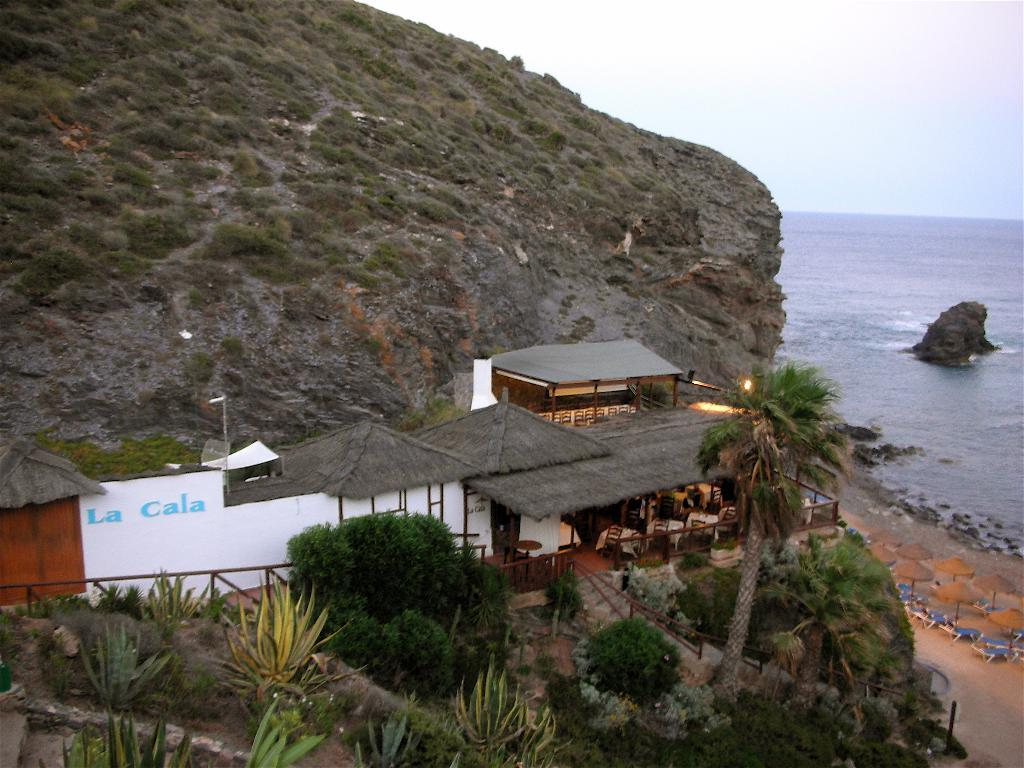What type of structure is present in the image? There is a building in the image. What type of vegetation can be seen in the image? There are trees, plants, and a mountain with grass in the image. What objects are on the ground in the image? There are umbrellas on the ground in the image. What is visible on the left side of the image? There is water on the left side of the image. What part of the natural environment is visible in the background of the image? The sky is visible in the background of the image. Where is the light bulb located in the image? There is no light bulb present in the image. What type of root can be seen growing from the mountain in the image? There is no root visible in the image; it features a mountain with grass. 